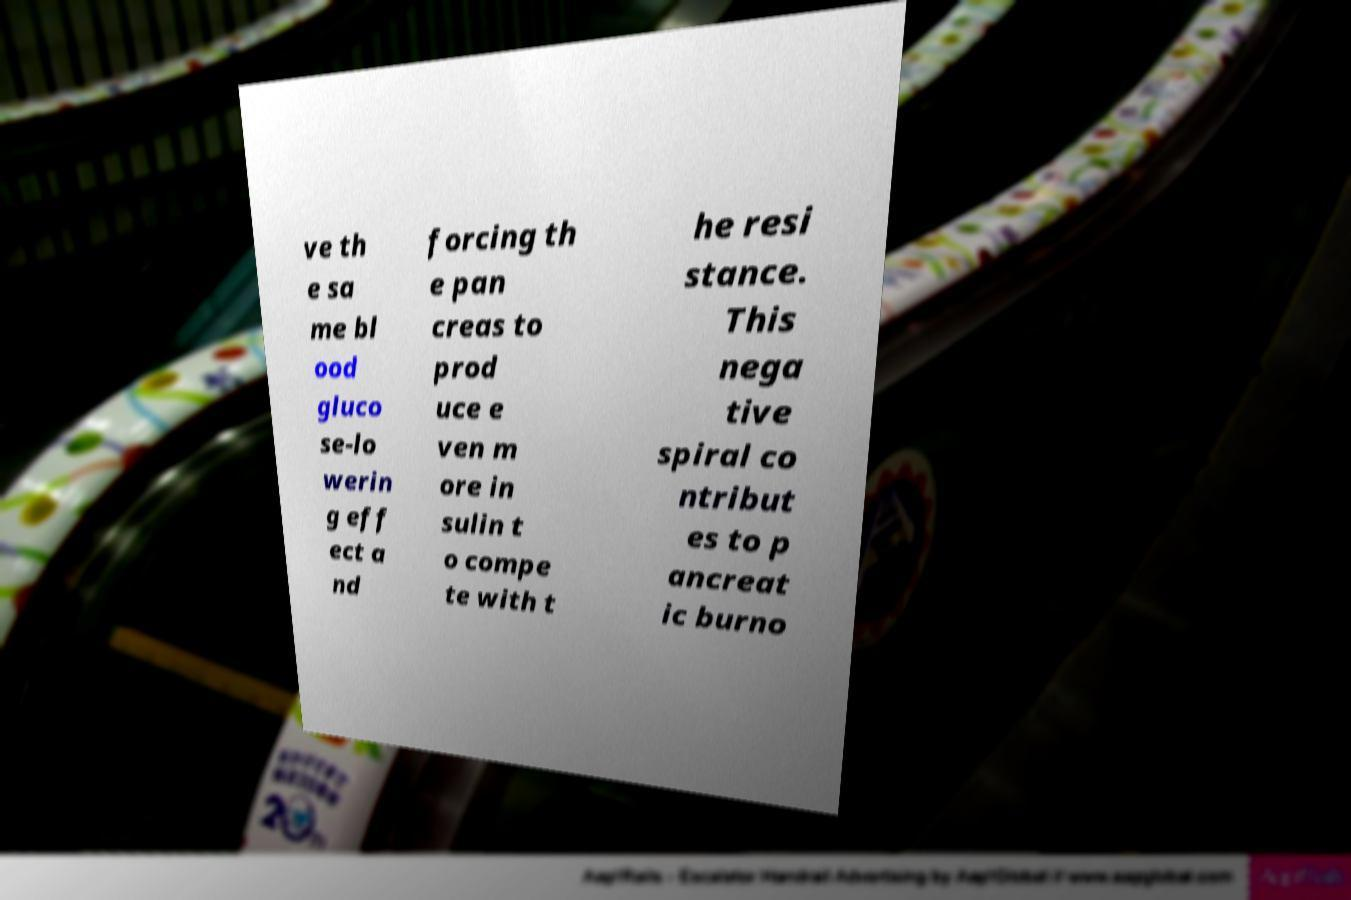For documentation purposes, I need the text within this image transcribed. Could you provide that? ve th e sa me bl ood gluco se-lo werin g eff ect a nd forcing th e pan creas to prod uce e ven m ore in sulin t o compe te with t he resi stance. This nega tive spiral co ntribut es to p ancreat ic burno 